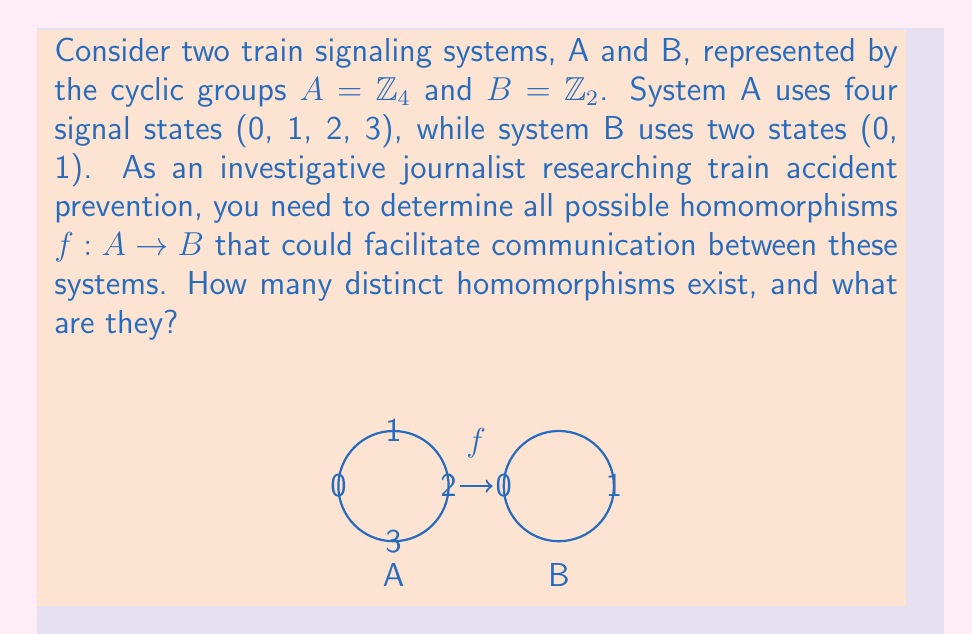Show me your answer to this math problem. To find the homomorphisms between systems A and B, we need to follow these steps:

1) Recall that for a homomorphism $f: A \rightarrow B$, we must have $f(a + a') = f(a) + f(a')$ for all $a, a' \in A$.

2) In $\mathbb{Z}_4$, the generator is 1, so we only need to determine $f(1)$. The value of $f(1)$ will determine the entire homomorphism.

3) Let's consider the possibilities for $f(1)$:

   Case 1: If $f(1) = 0$ in $\mathbb{Z}_2$
   Then $f(2) = f(1+1) = f(1) + f(1) = 0 + 0 = 0$
   $f(3) = f(1+2) = f(1) + f(2) = 0 + 0 = 0$
   $f(0) = f(4) = f(1+3) = f(1) + f(3) = 0 + 0 = 0$

   Case 2: If $f(1) = 1$ in $\mathbb{Z}_2$
   Then $f(2) = f(1+1) = f(1) + f(1) = 1 + 1 = 0$
   $f(3) = f(1+2) = f(1) + f(2) = 1 + 0 = 1$
   $f(0) = f(4) = f(1+3) = f(1) + f(3) = 1 + 1 = 0$

4) These are the only two possibilities that satisfy the homomorphism property.

5) Therefore, we have found two distinct homomorphisms:

   $f_1: A \rightarrow B$ defined by $f_1(x) = 0$ for all $x \in A$
   $f_2: A \rightarrow B$ defined by $f_2(0) = f_2(2) = 0$, $f_2(1) = f_2(3) = 1$

These homomorphisms represent potential ways to map the four-state system to the two-state system while preserving the algebraic structure.
Answer: 2 homomorphisms: $f_1(x) = 0$ and $f_2(x) = x \bmod 2$ 